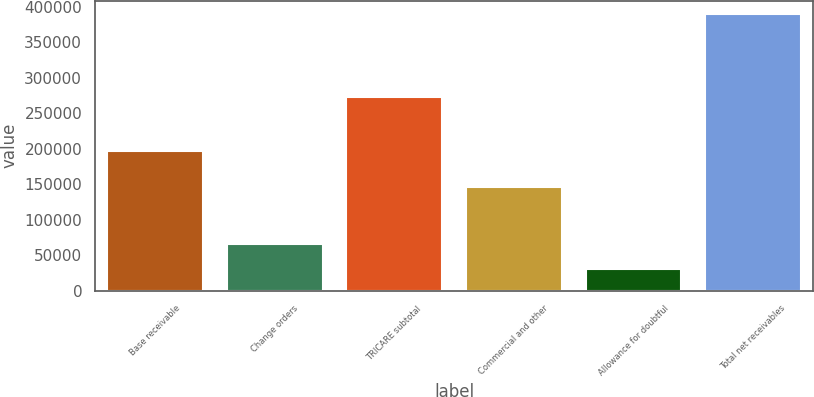Convert chart to OTSL. <chart><loc_0><loc_0><loc_500><loc_500><bar_chart><fcel>Base receivable<fcel>Change orders<fcel>TRICARE subtotal<fcel>Commercial and other<fcel>Allowance for doubtful<fcel>Total net receivables<nl><fcel>197544<fcel>66105.3<fcel>272747<fcel>146882<fcel>30178<fcel>389451<nl></chart> 